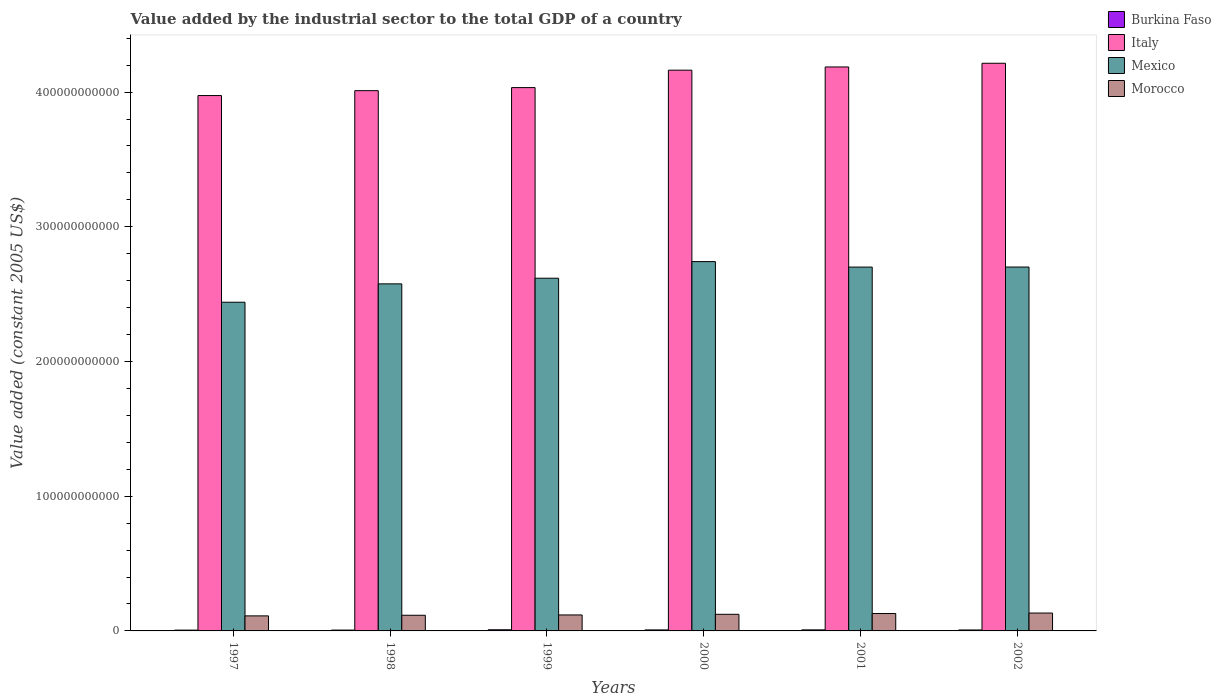How many different coloured bars are there?
Provide a short and direct response. 4. Are the number of bars per tick equal to the number of legend labels?
Ensure brevity in your answer.  Yes. Are the number of bars on each tick of the X-axis equal?
Provide a succinct answer. Yes. How many bars are there on the 1st tick from the left?
Keep it short and to the point. 4. How many bars are there on the 1st tick from the right?
Your answer should be very brief. 4. What is the label of the 3rd group of bars from the left?
Provide a short and direct response. 1999. In how many cases, is the number of bars for a given year not equal to the number of legend labels?
Your response must be concise. 0. What is the value added by the industrial sector in Morocco in 2000?
Offer a terse response. 1.23e+1. Across all years, what is the maximum value added by the industrial sector in Mexico?
Your answer should be compact. 2.74e+11. Across all years, what is the minimum value added by the industrial sector in Mexico?
Offer a terse response. 2.44e+11. In which year was the value added by the industrial sector in Morocco maximum?
Make the answer very short. 2002. In which year was the value added by the industrial sector in Mexico minimum?
Give a very brief answer. 1997. What is the total value added by the industrial sector in Morocco in the graph?
Ensure brevity in your answer.  7.32e+1. What is the difference between the value added by the industrial sector in Italy in 1997 and that in 2002?
Your answer should be very brief. -2.40e+1. What is the difference between the value added by the industrial sector in Burkina Faso in 2000 and the value added by the industrial sector in Italy in 2001?
Your answer should be compact. -4.18e+11. What is the average value added by the industrial sector in Mexico per year?
Provide a succinct answer. 2.63e+11. In the year 2002, what is the difference between the value added by the industrial sector in Burkina Faso and value added by the industrial sector in Mexico?
Provide a succinct answer. -2.69e+11. In how many years, is the value added by the industrial sector in Burkina Faso greater than 320000000000 US$?
Your response must be concise. 0. What is the ratio of the value added by the industrial sector in Burkina Faso in 1997 to that in 2000?
Your response must be concise. 0.79. Is the value added by the industrial sector in Mexico in 2000 less than that in 2002?
Offer a terse response. No. What is the difference between the highest and the second highest value added by the industrial sector in Burkina Faso?
Provide a succinct answer. 8.05e+07. What is the difference between the highest and the lowest value added by the industrial sector in Burkina Faso?
Offer a terse response. 2.57e+08. In how many years, is the value added by the industrial sector in Morocco greater than the average value added by the industrial sector in Morocco taken over all years?
Provide a succinct answer. 3. Is the sum of the value added by the industrial sector in Burkina Faso in 1997 and 2001 greater than the maximum value added by the industrial sector in Morocco across all years?
Your response must be concise. No. Is it the case that in every year, the sum of the value added by the industrial sector in Morocco and value added by the industrial sector in Burkina Faso is greater than the sum of value added by the industrial sector in Mexico and value added by the industrial sector in Italy?
Your response must be concise. No. Is it the case that in every year, the sum of the value added by the industrial sector in Burkina Faso and value added by the industrial sector in Mexico is greater than the value added by the industrial sector in Morocco?
Your answer should be very brief. Yes. How many years are there in the graph?
Offer a very short reply. 6. What is the difference between two consecutive major ticks on the Y-axis?
Provide a succinct answer. 1.00e+11. Where does the legend appear in the graph?
Offer a very short reply. Top right. How are the legend labels stacked?
Give a very brief answer. Vertical. What is the title of the graph?
Your answer should be compact. Value added by the industrial sector to the total GDP of a country. What is the label or title of the Y-axis?
Keep it short and to the point. Value added (constant 2005 US$). What is the Value added (constant 2005 US$) in Burkina Faso in 1997?
Your answer should be compact. 5.94e+08. What is the Value added (constant 2005 US$) of Italy in 1997?
Ensure brevity in your answer.  3.97e+11. What is the Value added (constant 2005 US$) of Mexico in 1997?
Offer a terse response. 2.44e+11. What is the Value added (constant 2005 US$) in Morocco in 1997?
Keep it short and to the point. 1.12e+1. What is the Value added (constant 2005 US$) of Burkina Faso in 1998?
Give a very brief answer. 6.20e+08. What is the Value added (constant 2005 US$) of Italy in 1998?
Provide a short and direct response. 4.01e+11. What is the Value added (constant 2005 US$) of Mexico in 1998?
Give a very brief answer. 2.58e+11. What is the Value added (constant 2005 US$) in Morocco in 1998?
Provide a succinct answer. 1.16e+1. What is the Value added (constant 2005 US$) in Burkina Faso in 1999?
Make the answer very short. 8.51e+08. What is the Value added (constant 2005 US$) of Italy in 1999?
Offer a terse response. 4.03e+11. What is the Value added (constant 2005 US$) of Mexico in 1999?
Ensure brevity in your answer.  2.62e+11. What is the Value added (constant 2005 US$) in Morocco in 1999?
Keep it short and to the point. 1.19e+1. What is the Value added (constant 2005 US$) of Burkina Faso in 2000?
Your response must be concise. 7.52e+08. What is the Value added (constant 2005 US$) of Italy in 2000?
Ensure brevity in your answer.  4.16e+11. What is the Value added (constant 2005 US$) in Mexico in 2000?
Make the answer very short. 2.74e+11. What is the Value added (constant 2005 US$) of Morocco in 2000?
Your answer should be very brief. 1.23e+1. What is the Value added (constant 2005 US$) in Burkina Faso in 2001?
Give a very brief answer. 7.71e+08. What is the Value added (constant 2005 US$) in Italy in 2001?
Ensure brevity in your answer.  4.19e+11. What is the Value added (constant 2005 US$) of Mexico in 2001?
Give a very brief answer. 2.70e+11. What is the Value added (constant 2005 US$) in Morocco in 2001?
Provide a succinct answer. 1.29e+1. What is the Value added (constant 2005 US$) of Burkina Faso in 2002?
Offer a very short reply. 6.98e+08. What is the Value added (constant 2005 US$) in Italy in 2002?
Make the answer very short. 4.21e+11. What is the Value added (constant 2005 US$) of Mexico in 2002?
Ensure brevity in your answer.  2.70e+11. What is the Value added (constant 2005 US$) of Morocco in 2002?
Offer a terse response. 1.33e+1. Across all years, what is the maximum Value added (constant 2005 US$) of Burkina Faso?
Provide a short and direct response. 8.51e+08. Across all years, what is the maximum Value added (constant 2005 US$) in Italy?
Offer a very short reply. 4.21e+11. Across all years, what is the maximum Value added (constant 2005 US$) in Mexico?
Offer a terse response. 2.74e+11. Across all years, what is the maximum Value added (constant 2005 US$) of Morocco?
Give a very brief answer. 1.33e+1. Across all years, what is the minimum Value added (constant 2005 US$) in Burkina Faso?
Give a very brief answer. 5.94e+08. Across all years, what is the minimum Value added (constant 2005 US$) of Italy?
Your answer should be very brief. 3.97e+11. Across all years, what is the minimum Value added (constant 2005 US$) of Mexico?
Your answer should be very brief. 2.44e+11. Across all years, what is the minimum Value added (constant 2005 US$) of Morocco?
Give a very brief answer. 1.12e+1. What is the total Value added (constant 2005 US$) in Burkina Faso in the graph?
Keep it short and to the point. 4.29e+09. What is the total Value added (constant 2005 US$) of Italy in the graph?
Offer a terse response. 2.46e+12. What is the total Value added (constant 2005 US$) of Mexico in the graph?
Your answer should be compact. 1.58e+12. What is the total Value added (constant 2005 US$) in Morocco in the graph?
Ensure brevity in your answer.  7.32e+1. What is the difference between the Value added (constant 2005 US$) in Burkina Faso in 1997 and that in 1998?
Provide a succinct answer. -2.58e+07. What is the difference between the Value added (constant 2005 US$) in Italy in 1997 and that in 1998?
Give a very brief answer. -3.63e+09. What is the difference between the Value added (constant 2005 US$) of Mexico in 1997 and that in 1998?
Your answer should be compact. -1.36e+1. What is the difference between the Value added (constant 2005 US$) in Morocco in 1997 and that in 1998?
Your response must be concise. -4.59e+08. What is the difference between the Value added (constant 2005 US$) in Burkina Faso in 1997 and that in 1999?
Keep it short and to the point. -2.57e+08. What is the difference between the Value added (constant 2005 US$) in Italy in 1997 and that in 1999?
Give a very brief answer. -5.90e+09. What is the difference between the Value added (constant 2005 US$) in Mexico in 1997 and that in 1999?
Your answer should be compact. -1.78e+1. What is the difference between the Value added (constant 2005 US$) in Morocco in 1997 and that in 1999?
Your answer should be very brief. -6.90e+08. What is the difference between the Value added (constant 2005 US$) of Burkina Faso in 1997 and that in 2000?
Your response must be concise. -1.57e+08. What is the difference between the Value added (constant 2005 US$) of Italy in 1997 and that in 2000?
Ensure brevity in your answer.  -1.88e+1. What is the difference between the Value added (constant 2005 US$) in Mexico in 1997 and that in 2000?
Your answer should be compact. -3.02e+1. What is the difference between the Value added (constant 2005 US$) in Morocco in 1997 and that in 2000?
Keep it short and to the point. -1.17e+09. What is the difference between the Value added (constant 2005 US$) of Burkina Faso in 1997 and that in 2001?
Your answer should be compact. -1.76e+08. What is the difference between the Value added (constant 2005 US$) of Italy in 1997 and that in 2001?
Your response must be concise. -2.12e+1. What is the difference between the Value added (constant 2005 US$) of Mexico in 1997 and that in 2001?
Offer a terse response. -2.61e+1. What is the difference between the Value added (constant 2005 US$) of Morocco in 1997 and that in 2001?
Your answer should be compact. -1.75e+09. What is the difference between the Value added (constant 2005 US$) in Burkina Faso in 1997 and that in 2002?
Keep it short and to the point. -1.04e+08. What is the difference between the Value added (constant 2005 US$) of Italy in 1997 and that in 2002?
Your answer should be compact. -2.40e+1. What is the difference between the Value added (constant 2005 US$) of Mexico in 1997 and that in 2002?
Provide a short and direct response. -2.61e+1. What is the difference between the Value added (constant 2005 US$) of Morocco in 1997 and that in 2002?
Your response must be concise. -2.10e+09. What is the difference between the Value added (constant 2005 US$) of Burkina Faso in 1998 and that in 1999?
Make the answer very short. -2.31e+08. What is the difference between the Value added (constant 2005 US$) of Italy in 1998 and that in 1999?
Provide a short and direct response. -2.27e+09. What is the difference between the Value added (constant 2005 US$) of Mexico in 1998 and that in 1999?
Offer a terse response. -4.21e+09. What is the difference between the Value added (constant 2005 US$) of Morocco in 1998 and that in 1999?
Offer a terse response. -2.32e+08. What is the difference between the Value added (constant 2005 US$) in Burkina Faso in 1998 and that in 2000?
Provide a short and direct response. -1.32e+08. What is the difference between the Value added (constant 2005 US$) of Italy in 1998 and that in 2000?
Give a very brief answer. -1.52e+1. What is the difference between the Value added (constant 2005 US$) of Mexico in 1998 and that in 2000?
Offer a very short reply. -1.65e+1. What is the difference between the Value added (constant 2005 US$) in Morocco in 1998 and that in 2000?
Your answer should be very brief. -7.09e+08. What is the difference between the Value added (constant 2005 US$) of Burkina Faso in 1998 and that in 2001?
Ensure brevity in your answer.  -1.50e+08. What is the difference between the Value added (constant 2005 US$) in Italy in 1998 and that in 2001?
Provide a short and direct response. -1.76e+1. What is the difference between the Value added (constant 2005 US$) in Mexico in 1998 and that in 2001?
Offer a very short reply. -1.25e+1. What is the difference between the Value added (constant 2005 US$) of Morocco in 1998 and that in 2001?
Your response must be concise. -1.29e+09. What is the difference between the Value added (constant 2005 US$) of Burkina Faso in 1998 and that in 2002?
Your answer should be very brief. -7.83e+07. What is the difference between the Value added (constant 2005 US$) in Italy in 1998 and that in 2002?
Ensure brevity in your answer.  -2.03e+1. What is the difference between the Value added (constant 2005 US$) in Mexico in 1998 and that in 2002?
Ensure brevity in your answer.  -1.25e+1. What is the difference between the Value added (constant 2005 US$) in Morocco in 1998 and that in 2002?
Your response must be concise. -1.65e+09. What is the difference between the Value added (constant 2005 US$) of Burkina Faso in 1999 and that in 2000?
Offer a terse response. 9.93e+07. What is the difference between the Value added (constant 2005 US$) of Italy in 1999 and that in 2000?
Provide a succinct answer. -1.29e+1. What is the difference between the Value added (constant 2005 US$) of Mexico in 1999 and that in 2000?
Give a very brief answer. -1.23e+1. What is the difference between the Value added (constant 2005 US$) of Morocco in 1999 and that in 2000?
Make the answer very short. -4.78e+08. What is the difference between the Value added (constant 2005 US$) in Burkina Faso in 1999 and that in 2001?
Offer a very short reply. 8.05e+07. What is the difference between the Value added (constant 2005 US$) in Italy in 1999 and that in 2001?
Your answer should be compact. -1.53e+1. What is the difference between the Value added (constant 2005 US$) of Mexico in 1999 and that in 2001?
Your answer should be very brief. -8.25e+09. What is the difference between the Value added (constant 2005 US$) of Morocco in 1999 and that in 2001?
Keep it short and to the point. -1.06e+09. What is the difference between the Value added (constant 2005 US$) in Burkina Faso in 1999 and that in 2002?
Your answer should be compact. 1.53e+08. What is the difference between the Value added (constant 2005 US$) of Italy in 1999 and that in 2002?
Ensure brevity in your answer.  -1.81e+1. What is the difference between the Value added (constant 2005 US$) in Mexico in 1999 and that in 2002?
Keep it short and to the point. -8.29e+09. What is the difference between the Value added (constant 2005 US$) of Morocco in 1999 and that in 2002?
Keep it short and to the point. -1.41e+09. What is the difference between the Value added (constant 2005 US$) in Burkina Faso in 2000 and that in 2001?
Make the answer very short. -1.89e+07. What is the difference between the Value added (constant 2005 US$) of Italy in 2000 and that in 2001?
Provide a short and direct response. -2.38e+09. What is the difference between the Value added (constant 2005 US$) in Mexico in 2000 and that in 2001?
Give a very brief answer. 4.07e+09. What is the difference between the Value added (constant 2005 US$) in Morocco in 2000 and that in 2001?
Your answer should be very brief. -5.85e+08. What is the difference between the Value added (constant 2005 US$) in Burkina Faso in 2000 and that in 2002?
Provide a short and direct response. 5.33e+07. What is the difference between the Value added (constant 2005 US$) of Italy in 2000 and that in 2002?
Your answer should be compact. -5.13e+09. What is the difference between the Value added (constant 2005 US$) of Mexico in 2000 and that in 2002?
Your response must be concise. 4.03e+09. What is the difference between the Value added (constant 2005 US$) in Morocco in 2000 and that in 2002?
Ensure brevity in your answer.  -9.36e+08. What is the difference between the Value added (constant 2005 US$) of Burkina Faso in 2001 and that in 2002?
Provide a short and direct response. 7.21e+07. What is the difference between the Value added (constant 2005 US$) in Italy in 2001 and that in 2002?
Keep it short and to the point. -2.75e+09. What is the difference between the Value added (constant 2005 US$) in Mexico in 2001 and that in 2002?
Provide a succinct answer. -3.79e+07. What is the difference between the Value added (constant 2005 US$) in Morocco in 2001 and that in 2002?
Your answer should be compact. -3.51e+08. What is the difference between the Value added (constant 2005 US$) of Burkina Faso in 1997 and the Value added (constant 2005 US$) of Italy in 1998?
Your answer should be very brief. -4.00e+11. What is the difference between the Value added (constant 2005 US$) of Burkina Faso in 1997 and the Value added (constant 2005 US$) of Mexico in 1998?
Your answer should be compact. -2.57e+11. What is the difference between the Value added (constant 2005 US$) in Burkina Faso in 1997 and the Value added (constant 2005 US$) in Morocco in 1998?
Your answer should be very brief. -1.10e+1. What is the difference between the Value added (constant 2005 US$) of Italy in 1997 and the Value added (constant 2005 US$) of Mexico in 1998?
Your answer should be compact. 1.40e+11. What is the difference between the Value added (constant 2005 US$) of Italy in 1997 and the Value added (constant 2005 US$) of Morocco in 1998?
Your response must be concise. 3.86e+11. What is the difference between the Value added (constant 2005 US$) of Mexico in 1997 and the Value added (constant 2005 US$) of Morocco in 1998?
Ensure brevity in your answer.  2.32e+11. What is the difference between the Value added (constant 2005 US$) of Burkina Faso in 1997 and the Value added (constant 2005 US$) of Italy in 1999?
Give a very brief answer. -4.03e+11. What is the difference between the Value added (constant 2005 US$) in Burkina Faso in 1997 and the Value added (constant 2005 US$) in Mexico in 1999?
Provide a short and direct response. -2.61e+11. What is the difference between the Value added (constant 2005 US$) of Burkina Faso in 1997 and the Value added (constant 2005 US$) of Morocco in 1999?
Make the answer very short. -1.13e+1. What is the difference between the Value added (constant 2005 US$) of Italy in 1997 and the Value added (constant 2005 US$) of Mexico in 1999?
Give a very brief answer. 1.36e+11. What is the difference between the Value added (constant 2005 US$) in Italy in 1997 and the Value added (constant 2005 US$) in Morocco in 1999?
Give a very brief answer. 3.86e+11. What is the difference between the Value added (constant 2005 US$) of Mexico in 1997 and the Value added (constant 2005 US$) of Morocco in 1999?
Offer a terse response. 2.32e+11. What is the difference between the Value added (constant 2005 US$) in Burkina Faso in 1997 and the Value added (constant 2005 US$) in Italy in 2000?
Provide a short and direct response. -4.16e+11. What is the difference between the Value added (constant 2005 US$) in Burkina Faso in 1997 and the Value added (constant 2005 US$) in Mexico in 2000?
Your answer should be compact. -2.74e+11. What is the difference between the Value added (constant 2005 US$) of Burkina Faso in 1997 and the Value added (constant 2005 US$) of Morocco in 2000?
Your response must be concise. -1.17e+1. What is the difference between the Value added (constant 2005 US$) of Italy in 1997 and the Value added (constant 2005 US$) of Mexico in 2000?
Your response must be concise. 1.23e+11. What is the difference between the Value added (constant 2005 US$) in Italy in 1997 and the Value added (constant 2005 US$) in Morocco in 2000?
Ensure brevity in your answer.  3.85e+11. What is the difference between the Value added (constant 2005 US$) in Mexico in 1997 and the Value added (constant 2005 US$) in Morocco in 2000?
Provide a succinct answer. 2.32e+11. What is the difference between the Value added (constant 2005 US$) in Burkina Faso in 1997 and the Value added (constant 2005 US$) in Italy in 2001?
Offer a very short reply. -4.18e+11. What is the difference between the Value added (constant 2005 US$) in Burkina Faso in 1997 and the Value added (constant 2005 US$) in Mexico in 2001?
Keep it short and to the point. -2.70e+11. What is the difference between the Value added (constant 2005 US$) of Burkina Faso in 1997 and the Value added (constant 2005 US$) of Morocco in 2001?
Offer a very short reply. -1.23e+1. What is the difference between the Value added (constant 2005 US$) in Italy in 1997 and the Value added (constant 2005 US$) in Mexico in 2001?
Keep it short and to the point. 1.27e+11. What is the difference between the Value added (constant 2005 US$) of Italy in 1997 and the Value added (constant 2005 US$) of Morocco in 2001?
Provide a short and direct response. 3.85e+11. What is the difference between the Value added (constant 2005 US$) in Mexico in 1997 and the Value added (constant 2005 US$) in Morocco in 2001?
Make the answer very short. 2.31e+11. What is the difference between the Value added (constant 2005 US$) in Burkina Faso in 1997 and the Value added (constant 2005 US$) in Italy in 2002?
Offer a terse response. -4.21e+11. What is the difference between the Value added (constant 2005 US$) in Burkina Faso in 1997 and the Value added (constant 2005 US$) in Mexico in 2002?
Ensure brevity in your answer.  -2.70e+11. What is the difference between the Value added (constant 2005 US$) in Burkina Faso in 1997 and the Value added (constant 2005 US$) in Morocco in 2002?
Make the answer very short. -1.27e+1. What is the difference between the Value added (constant 2005 US$) of Italy in 1997 and the Value added (constant 2005 US$) of Mexico in 2002?
Make the answer very short. 1.27e+11. What is the difference between the Value added (constant 2005 US$) of Italy in 1997 and the Value added (constant 2005 US$) of Morocco in 2002?
Offer a terse response. 3.84e+11. What is the difference between the Value added (constant 2005 US$) of Mexico in 1997 and the Value added (constant 2005 US$) of Morocco in 2002?
Offer a very short reply. 2.31e+11. What is the difference between the Value added (constant 2005 US$) of Burkina Faso in 1998 and the Value added (constant 2005 US$) of Italy in 1999?
Your response must be concise. -4.03e+11. What is the difference between the Value added (constant 2005 US$) in Burkina Faso in 1998 and the Value added (constant 2005 US$) in Mexico in 1999?
Give a very brief answer. -2.61e+11. What is the difference between the Value added (constant 2005 US$) of Burkina Faso in 1998 and the Value added (constant 2005 US$) of Morocco in 1999?
Provide a succinct answer. -1.12e+1. What is the difference between the Value added (constant 2005 US$) in Italy in 1998 and the Value added (constant 2005 US$) in Mexico in 1999?
Offer a very short reply. 1.39e+11. What is the difference between the Value added (constant 2005 US$) of Italy in 1998 and the Value added (constant 2005 US$) of Morocco in 1999?
Provide a succinct answer. 3.89e+11. What is the difference between the Value added (constant 2005 US$) of Mexico in 1998 and the Value added (constant 2005 US$) of Morocco in 1999?
Offer a very short reply. 2.46e+11. What is the difference between the Value added (constant 2005 US$) of Burkina Faso in 1998 and the Value added (constant 2005 US$) of Italy in 2000?
Your answer should be compact. -4.16e+11. What is the difference between the Value added (constant 2005 US$) in Burkina Faso in 1998 and the Value added (constant 2005 US$) in Mexico in 2000?
Your answer should be very brief. -2.74e+11. What is the difference between the Value added (constant 2005 US$) in Burkina Faso in 1998 and the Value added (constant 2005 US$) in Morocco in 2000?
Offer a very short reply. -1.17e+1. What is the difference between the Value added (constant 2005 US$) in Italy in 1998 and the Value added (constant 2005 US$) in Mexico in 2000?
Provide a short and direct response. 1.27e+11. What is the difference between the Value added (constant 2005 US$) in Italy in 1998 and the Value added (constant 2005 US$) in Morocco in 2000?
Provide a succinct answer. 3.89e+11. What is the difference between the Value added (constant 2005 US$) in Mexico in 1998 and the Value added (constant 2005 US$) in Morocco in 2000?
Your answer should be compact. 2.45e+11. What is the difference between the Value added (constant 2005 US$) in Burkina Faso in 1998 and the Value added (constant 2005 US$) in Italy in 2001?
Provide a short and direct response. -4.18e+11. What is the difference between the Value added (constant 2005 US$) of Burkina Faso in 1998 and the Value added (constant 2005 US$) of Mexico in 2001?
Make the answer very short. -2.69e+11. What is the difference between the Value added (constant 2005 US$) of Burkina Faso in 1998 and the Value added (constant 2005 US$) of Morocco in 2001?
Keep it short and to the point. -1.23e+1. What is the difference between the Value added (constant 2005 US$) of Italy in 1998 and the Value added (constant 2005 US$) of Mexico in 2001?
Keep it short and to the point. 1.31e+11. What is the difference between the Value added (constant 2005 US$) in Italy in 1998 and the Value added (constant 2005 US$) in Morocco in 2001?
Offer a very short reply. 3.88e+11. What is the difference between the Value added (constant 2005 US$) in Mexico in 1998 and the Value added (constant 2005 US$) in Morocco in 2001?
Offer a terse response. 2.45e+11. What is the difference between the Value added (constant 2005 US$) in Burkina Faso in 1998 and the Value added (constant 2005 US$) in Italy in 2002?
Provide a succinct answer. -4.21e+11. What is the difference between the Value added (constant 2005 US$) of Burkina Faso in 1998 and the Value added (constant 2005 US$) of Mexico in 2002?
Give a very brief answer. -2.70e+11. What is the difference between the Value added (constant 2005 US$) in Burkina Faso in 1998 and the Value added (constant 2005 US$) in Morocco in 2002?
Keep it short and to the point. -1.27e+1. What is the difference between the Value added (constant 2005 US$) of Italy in 1998 and the Value added (constant 2005 US$) of Mexico in 2002?
Keep it short and to the point. 1.31e+11. What is the difference between the Value added (constant 2005 US$) of Italy in 1998 and the Value added (constant 2005 US$) of Morocco in 2002?
Give a very brief answer. 3.88e+11. What is the difference between the Value added (constant 2005 US$) of Mexico in 1998 and the Value added (constant 2005 US$) of Morocco in 2002?
Your response must be concise. 2.44e+11. What is the difference between the Value added (constant 2005 US$) in Burkina Faso in 1999 and the Value added (constant 2005 US$) in Italy in 2000?
Provide a short and direct response. -4.15e+11. What is the difference between the Value added (constant 2005 US$) in Burkina Faso in 1999 and the Value added (constant 2005 US$) in Mexico in 2000?
Provide a short and direct response. -2.73e+11. What is the difference between the Value added (constant 2005 US$) in Burkina Faso in 1999 and the Value added (constant 2005 US$) in Morocco in 2000?
Provide a succinct answer. -1.15e+1. What is the difference between the Value added (constant 2005 US$) of Italy in 1999 and the Value added (constant 2005 US$) of Mexico in 2000?
Ensure brevity in your answer.  1.29e+11. What is the difference between the Value added (constant 2005 US$) in Italy in 1999 and the Value added (constant 2005 US$) in Morocco in 2000?
Offer a terse response. 3.91e+11. What is the difference between the Value added (constant 2005 US$) in Mexico in 1999 and the Value added (constant 2005 US$) in Morocco in 2000?
Offer a terse response. 2.50e+11. What is the difference between the Value added (constant 2005 US$) in Burkina Faso in 1999 and the Value added (constant 2005 US$) in Italy in 2001?
Keep it short and to the point. -4.18e+11. What is the difference between the Value added (constant 2005 US$) in Burkina Faso in 1999 and the Value added (constant 2005 US$) in Mexico in 2001?
Your answer should be very brief. -2.69e+11. What is the difference between the Value added (constant 2005 US$) of Burkina Faso in 1999 and the Value added (constant 2005 US$) of Morocco in 2001?
Provide a succinct answer. -1.21e+1. What is the difference between the Value added (constant 2005 US$) in Italy in 1999 and the Value added (constant 2005 US$) in Mexico in 2001?
Ensure brevity in your answer.  1.33e+11. What is the difference between the Value added (constant 2005 US$) in Italy in 1999 and the Value added (constant 2005 US$) in Morocco in 2001?
Make the answer very short. 3.90e+11. What is the difference between the Value added (constant 2005 US$) in Mexico in 1999 and the Value added (constant 2005 US$) in Morocco in 2001?
Give a very brief answer. 2.49e+11. What is the difference between the Value added (constant 2005 US$) of Burkina Faso in 1999 and the Value added (constant 2005 US$) of Italy in 2002?
Offer a terse response. -4.21e+11. What is the difference between the Value added (constant 2005 US$) in Burkina Faso in 1999 and the Value added (constant 2005 US$) in Mexico in 2002?
Ensure brevity in your answer.  -2.69e+11. What is the difference between the Value added (constant 2005 US$) of Burkina Faso in 1999 and the Value added (constant 2005 US$) of Morocco in 2002?
Provide a short and direct response. -1.24e+1. What is the difference between the Value added (constant 2005 US$) of Italy in 1999 and the Value added (constant 2005 US$) of Mexico in 2002?
Keep it short and to the point. 1.33e+11. What is the difference between the Value added (constant 2005 US$) in Italy in 1999 and the Value added (constant 2005 US$) in Morocco in 2002?
Provide a succinct answer. 3.90e+11. What is the difference between the Value added (constant 2005 US$) in Mexico in 1999 and the Value added (constant 2005 US$) in Morocco in 2002?
Ensure brevity in your answer.  2.49e+11. What is the difference between the Value added (constant 2005 US$) in Burkina Faso in 2000 and the Value added (constant 2005 US$) in Italy in 2001?
Offer a very short reply. -4.18e+11. What is the difference between the Value added (constant 2005 US$) of Burkina Faso in 2000 and the Value added (constant 2005 US$) of Mexico in 2001?
Your answer should be compact. -2.69e+11. What is the difference between the Value added (constant 2005 US$) in Burkina Faso in 2000 and the Value added (constant 2005 US$) in Morocco in 2001?
Your answer should be very brief. -1.22e+1. What is the difference between the Value added (constant 2005 US$) in Italy in 2000 and the Value added (constant 2005 US$) in Mexico in 2001?
Offer a terse response. 1.46e+11. What is the difference between the Value added (constant 2005 US$) of Italy in 2000 and the Value added (constant 2005 US$) of Morocco in 2001?
Offer a very short reply. 4.03e+11. What is the difference between the Value added (constant 2005 US$) of Mexico in 2000 and the Value added (constant 2005 US$) of Morocco in 2001?
Provide a succinct answer. 2.61e+11. What is the difference between the Value added (constant 2005 US$) in Burkina Faso in 2000 and the Value added (constant 2005 US$) in Italy in 2002?
Your answer should be very brief. -4.21e+11. What is the difference between the Value added (constant 2005 US$) in Burkina Faso in 2000 and the Value added (constant 2005 US$) in Mexico in 2002?
Make the answer very short. -2.69e+11. What is the difference between the Value added (constant 2005 US$) in Burkina Faso in 2000 and the Value added (constant 2005 US$) in Morocco in 2002?
Your response must be concise. -1.25e+1. What is the difference between the Value added (constant 2005 US$) in Italy in 2000 and the Value added (constant 2005 US$) in Mexico in 2002?
Offer a terse response. 1.46e+11. What is the difference between the Value added (constant 2005 US$) of Italy in 2000 and the Value added (constant 2005 US$) of Morocco in 2002?
Your response must be concise. 4.03e+11. What is the difference between the Value added (constant 2005 US$) of Mexico in 2000 and the Value added (constant 2005 US$) of Morocco in 2002?
Your response must be concise. 2.61e+11. What is the difference between the Value added (constant 2005 US$) of Burkina Faso in 2001 and the Value added (constant 2005 US$) of Italy in 2002?
Provide a succinct answer. -4.21e+11. What is the difference between the Value added (constant 2005 US$) in Burkina Faso in 2001 and the Value added (constant 2005 US$) in Mexico in 2002?
Keep it short and to the point. -2.69e+11. What is the difference between the Value added (constant 2005 US$) in Burkina Faso in 2001 and the Value added (constant 2005 US$) in Morocco in 2002?
Your answer should be very brief. -1.25e+1. What is the difference between the Value added (constant 2005 US$) of Italy in 2001 and the Value added (constant 2005 US$) of Mexico in 2002?
Your answer should be compact. 1.49e+11. What is the difference between the Value added (constant 2005 US$) in Italy in 2001 and the Value added (constant 2005 US$) in Morocco in 2002?
Your answer should be very brief. 4.05e+11. What is the difference between the Value added (constant 2005 US$) of Mexico in 2001 and the Value added (constant 2005 US$) of Morocco in 2002?
Provide a short and direct response. 2.57e+11. What is the average Value added (constant 2005 US$) of Burkina Faso per year?
Your answer should be compact. 7.14e+08. What is the average Value added (constant 2005 US$) in Italy per year?
Make the answer very short. 4.10e+11. What is the average Value added (constant 2005 US$) in Mexico per year?
Make the answer very short. 2.63e+11. What is the average Value added (constant 2005 US$) in Morocco per year?
Make the answer very short. 1.22e+1. In the year 1997, what is the difference between the Value added (constant 2005 US$) in Burkina Faso and Value added (constant 2005 US$) in Italy?
Offer a very short reply. -3.97e+11. In the year 1997, what is the difference between the Value added (constant 2005 US$) of Burkina Faso and Value added (constant 2005 US$) of Mexico?
Offer a very short reply. -2.43e+11. In the year 1997, what is the difference between the Value added (constant 2005 US$) of Burkina Faso and Value added (constant 2005 US$) of Morocco?
Provide a succinct answer. -1.06e+1. In the year 1997, what is the difference between the Value added (constant 2005 US$) in Italy and Value added (constant 2005 US$) in Mexico?
Make the answer very short. 1.53e+11. In the year 1997, what is the difference between the Value added (constant 2005 US$) of Italy and Value added (constant 2005 US$) of Morocco?
Make the answer very short. 3.86e+11. In the year 1997, what is the difference between the Value added (constant 2005 US$) of Mexico and Value added (constant 2005 US$) of Morocco?
Offer a very short reply. 2.33e+11. In the year 1998, what is the difference between the Value added (constant 2005 US$) of Burkina Faso and Value added (constant 2005 US$) of Italy?
Make the answer very short. -4.00e+11. In the year 1998, what is the difference between the Value added (constant 2005 US$) in Burkina Faso and Value added (constant 2005 US$) in Mexico?
Your response must be concise. -2.57e+11. In the year 1998, what is the difference between the Value added (constant 2005 US$) in Burkina Faso and Value added (constant 2005 US$) in Morocco?
Your answer should be very brief. -1.10e+1. In the year 1998, what is the difference between the Value added (constant 2005 US$) in Italy and Value added (constant 2005 US$) in Mexico?
Provide a succinct answer. 1.43e+11. In the year 1998, what is the difference between the Value added (constant 2005 US$) of Italy and Value added (constant 2005 US$) of Morocco?
Your response must be concise. 3.89e+11. In the year 1998, what is the difference between the Value added (constant 2005 US$) of Mexico and Value added (constant 2005 US$) of Morocco?
Your answer should be compact. 2.46e+11. In the year 1999, what is the difference between the Value added (constant 2005 US$) in Burkina Faso and Value added (constant 2005 US$) in Italy?
Your response must be concise. -4.02e+11. In the year 1999, what is the difference between the Value added (constant 2005 US$) in Burkina Faso and Value added (constant 2005 US$) in Mexico?
Offer a terse response. -2.61e+11. In the year 1999, what is the difference between the Value added (constant 2005 US$) in Burkina Faso and Value added (constant 2005 US$) in Morocco?
Give a very brief answer. -1.10e+1. In the year 1999, what is the difference between the Value added (constant 2005 US$) in Italy and Value added (constant 2005 US$) in Mexico?
Your answer should be very brief. 1.41e+11. In the year 1999, what is the difference between the Value added (constant 2005 US$) in Italy and Value added (constant 2005 US$) in Morocco?
Make the answer very short. 3.91e+11. In the year 1999, what is the difference between the Value added (constant 2005 US$) in Mexico and Value added (constant 2005 US$) in Morocco?
Give a very brief answer. 2.50e+11. In the year 2000, what is the difference between the Value added (constant 2005 US$) in Burkina Faso and Value added (constant 2005 US$) in Italy?
Your answer should be very brief. -4.16e+11. In the year 2000, what is the difference between the Value added (constant 2005 US$) in Burkina Faso and Value added (constant 2005 US$) in Mexico?
Your response must be concise. -2.73e+11. In the year 2000, what is the difference between the Value added (constant 2005 US$) of Burkina Faso and Value added (constant 2005 US$) of Morocco?
Provide a succinct answer. -1.16e+1. In the year 2000, what is the difference between the Value added (constant 2005 US$) of Italy and Value added (constant 2005 US$) of Mexico?
Offer a very short reply. 1.42e+11. In the year 2000, what is the difference between the Value added (constant 2005 US$) in Italy and Value added (constant 2005 US$) in Morocco?
Your answer should be compact. 4.04e+11. In the year 2000, what is the difference between the Value added (constant 2005 US$) in Mexico and Value added (constant 2005 US$) in Morocco?
Offer a terse response. 2.62e+11. In the year 2001, what is the difference between the Value added (constant 2005 US$) in Burkina Faso and Value added (constant 2005 US$) in Italy?
Your answer should be very brief. -4.18e+11. In the year 2001, what is the difference between the Value added (constant 2005 US$) of Burkina Faso and Value added (constant 2005 US$) of Mexico?
Offer a very short reply. -2.69e+11. In the year 2001, what is the difference between the Value added (constant 2005 US$) of Burkina Faso and Value added (constant 2005 US$) of Morocco?
Make the answer very short. -1.21e+1. In the year 2001, what is the difference between the Value added (constant 2005 US$) of Italy and Value added (constant 2005 US$) of Mexico?
Your answer should be very brief. 1.49e+11. In the year 2001, what is the difference between the Value added (constant 2005 US$) of Italy and Value added (constant 2005 US$) of Morocco?
Provide a short and direct response. 4.06e+11. In the year 2001, what is the difference between the Value added (constant 2005 US$) of Mexico and Value added (constant 2005 US$) of Morocco?
Your answer should be compact. 2.57e+11. In the year 2002, what is the difference between the Value added (constant 2005 US$) in Burkina Faso and Value added (constant 2005 US$) in Italy?
Your answer should be very brief. -4.21e+11. In the year 2002, what is the difference between the Value added (constant 2005 US$) of Burkina Faso and Value added (constant 2005 US$) of Mexico?
Make the answer very short. -2.69e+11. In the year 2002, what is the difference between the Value added (constant 2005 US$) of Burkina Faso and Value added (constant 2005 US$) of Morocco?
Ensure brevity in your answer.  -1.26e+1. In the year 2002, what is the difference between the Value added (constant 2005 US$) of Italy and Value added (constant 2005 US$) of Mexico?
Offer a very short reply. 1.51e+11. In the year 2002, what is the difference between the Value added (constant 2005 US$) in Italy and Value added (constant 2005 US$) in Morocco?
Provide a short and direct response. 4.08e+11. In the year 2002, what is the difference between the Value added (constant 2005 US$) of Mexico and Value added (constant 2005 US$) of Morocco?
Offer a very short reply. 2.57e+11. What is the ratio of the Value added (constant 2005 US$) in Burkina Faso in 1997 to that in 1998?
Keep it short and to the point. 0.96. What is the ratio of the Value added (constant 2005 US$) of Mexico in 1997 to that in 1998?
Ensure brevity in your answer.  0.95. What is the ratio of the Value added (constant 2005 US$) of Morocco in 1997 to that in 1998?
Offer a very short reply. 0.96. What is the ratio of the Value added (constant 2005 US$) of Burkina Faso in 1997 to that in 1999?
Ensure brevity in your answer.  0.7. What is the ratio of the Value added (constant 2005 US$) in Italy in 1997 to that in 1999?
Offer a very short reply. 0.99. What is the ratio of the Value added (constant 2005 US$) of Mexico in 1997 to that in 1999?
Your response must be concise. 0.93. What is the ratio of the Value added (constant 2005 US$) in Morocco in 1997 to that in 1999?
Provide a succinct answer. 0.94. What is the ratio of the Value added (constant 2005 US$) in Burkina Faso in 1997 to that in 2000?
Make the answer very short. 0.79. What is the ratio of the Value added (constant 2005 US$) in Italy in 1997 to that in 2000?
Your response must be concise. 0.95. What is the ratio of the Value added (constant 2005 US$) of Mexico in 1997 to that in 2000?
Offer a very short reply. 0.89. What is the ratio of the Value added (constant 2005 US$) in Morocco in 1997 to that in 2000?
Provide a succinct answer. 0.91. What is the ratio of the Value added (constant 2005 US$) in Burkina Faso in 1997 to that in 2001?
Give a very brief answer. 0.77. What is the ratio of the Value added (constant 2005 US$) of Italy in 1997 to that in 2001?
Your response must be concise. 0.95. What is the ratio of the Value added (constant 2005 US$) in Mexico in 1997 to that in 2001?
Make the answer very short. 0.9. What is the ratio of the Value added (constant 2005 US$) of Morocco in 1997 to that in 2001?
Your answer should be compact. 0.86. What is the ratio of the Value added (constant 2005 US$) in Burkina Faso in 1997 to that in 2002?
Ensure brevity in your answer.  0.85. What is the ratio of the Value added (constant 2005 US$) of Italy in 1997 to that in 2002?
Your answer should be very brief. 0.94. What is the ratio of the Value added (constant 2005 US$) of Mexico in 1997 to that in 2002?
Your answer should be very brief. 0.9. What is the ratio of the Value added (constant 2005 US$) of Morocco in 1997 to that in 2002?
Offer a very short reply. 0.84. What is the ratio of the Value added (constant 2005 US$) in Burkina Faso in 1998 to that in 1999?
Offer a terse response. 0.73. What is the ratio of the Value added (constant 2005 US$) of Italy in 1998 to that in 1999?
Provide a succinct answer. 0.99. What is the ratio of the Value added (constant 2005 US$) in Mexico in 1998 to that in 1999?
Provide a short and direct response. 0.98. What is the ratio of the Value added (constant 2005 US$) in Morocco in 1998 to that in 1999?
Your response must be concise. 0.98. What is the ratio of the Value added (constant 2005 US$) of Burkina Faso in 1998 to that in 2000?
Keep it short and to the point. 0.82. What is the ratio of the Value added (constant 2005 US$) in Italy in 1998 to that in 2000?
Offer a very short reply. 0.96. What is the ratio of the Value added (constant 2005 US$) in Mexico in 1998 to that in 2000?
Your answer should be very brief. 0.94. What is the ratio of the Value added (constant 2005 US$) of Morocco in 1998 to that in 2000?
Your answer should be compact. 0.94. What is the ratio of the Value added (constant 2005 US$) in Burkina Faso in 1998 to that in 2001?
Offer a very short reply. 0.8. What is the ratio of the Value added (constant 2005 US$) in Italy in 1998 to that in 2001?
Ensure brevity in your answer.  0.96. What is the ratio of the Value added (constant 2005 US$) of Mexico in 1998 to that in 2001?
Provide a succinct answer. 0.95. What is the ratio of the Value added (constant 2005 US$) of Morocco in 1998 to that in 2001?
Your answer should be very brief. 0.9. What is the ratio of the Value added (constant 2005 US$) of Burkina Faso in 1998 to that in 2002?
Provide a succinct answer. 0.89. What is the ratio of the Value added (constant 2005 US$) of Italy in 1998 to that in 2002?
Your answer should be compact. 0.95. What is the ratio of the Value added (constant 2005 US$) of Mexico in 1998 to that in 2002?
Offer a terse response. 0.95. What is the ratio of the Value added (constant 2005 US$) in Morocco in 1998 to that in 2002?
Provide a succinct answer. 0.88. What is the ratio of the Value added (constant 2005 US$) of Burkina Faso in 1999 to that in 2000?
Make the answer very short. 1.13. What is the ratio of the Value added (constant 2005 US$) in Italy in 1999 to that in 2000?
Provide a succinct answer. 0.97. What is the ratio of the Value added (constant 2005 US$) in Mexico in 1999 to that in 2000?
Your answer should be compact. 0.95. What is the ratio of the Value added (constant 2005 US$) of Morocco in 1999 to that in 2000?
Your answer should be very brief. 0.96. What is the ratio of the Value added (constant 2005 US$) in Burkina Faso in 1999 to that in 2001?
Your answer should be compact. 1.1. What is the ratio of the Value added (constant 2005 US$) in Italy in 1999 to that in 2001?
Your response must be concise. 0.96. What is the ratio of the Value added (constant 2005 US$) of Mexico in 1999 to that in 2001?
Your response must be concise. 0.97. What is the ratio of the Value added (constant 2005 US$) in Morocco in 1999 to that in 2001?
Your answer should be very brief. 0.92. What is the ratio of the Value added (constant 2005 US$) in Burkina Faso in 1999 to that in 2002?
Your answer should be compact. 1.22. What is the ratio of the Value added (constant 2005 US$) of Italy in 1999 to that in 2002?
Your answer should be compact. 0.96. What is the ratio of the Value added (constant 2005 US$) of Mexico in 1999 to that in 2002?
Give a very brief answer. 0.97. What is the ratio of the Value added (constant 2005 US$) of Morocco in 1999 to that in 2002?
Your answer should be very brief. 0.89. What is the ratio of the Value added (constant 2005 US$) in Burkina Faso in 2000 to that in 2001?
Ensure brevity in your answer.  0.98. What is the ratio of the Value added (constant 2005 US$) in Mexico in 2000 to that in 2001?
Give a very brief answer. 1.02. What is the ratio of the Value added (constant 2005 US$) of Morocco in 2000 to that in 2001?
Keep it short and to the point. 0.95. What is the ratio of the Value added (constant 2005 US$) of Burkina Faso in 2000 to that in 2002?
Ensure brevity in your answer.  1.08. What is the ratio of the Value added (constant 2005 US$) in Italy in 2000 to that in 2002?
Make the answer very short. 0.99. What is the ratio of the Value added (constant 2005 US$) of Mexico in 2000 to that in 2002?
Offer a very short reply. 1.01. What is the ratio of the Value added (constant 2005 US$) of Morocco in 2000 to that in 2002?
Give a very brief answer. 0.93. What is the ratio of the Value added (constant 2005 US$) in Burkina Faso in 2001 to that in 2002?
Your response must be concise. 1.1. What is the ratio of the Value added (constant 2005 US$) of Italy in 2001 to that in 2002?
Ensure brevity in your answer.  0.99. What is the ratio of the Value added (constant 2005 US$) in Morocco in 2001 to that in 2002?
Make the answer very short. 0.97. What is the difference between the highest and the second highest Value added (constant 2005 US$) in Burkina Faso?
Give a very brief answer. 8.05e+07. What is the difference between the highest and the second highest Value added (constant 2005 US$) in Italy?
Give a very brief answer. 2.75e+09. What is the difference between the highest and the second highest Value added (constant 2005 US$) in Mexico?
Your answer should be compact. 4.03e+09. What is the difference between the highest and the second highest Value added (constant 2005 US$) of Morocco?
Your answer should be compact. 3.51e+08. What is the difference between the highest and the lowest Value added (constant 2005 US$) of Burkina Faso?
Offer a very short reply. 2.57e+08. What is the difference between the highest and the lowest Value added (constant 2005 US$) of Italy?
Provide a succinct answer. 2.40e+1. What is the difference between the highest and the lowest Value added (constant 2005 US$) in Mexico?
Provide a short and direct response. 3.02e+1. What is the difference between the highest and the lowest Value added (constant 2005 US$) in Morocco?
Your answer should be compact. 2.10e+09. 